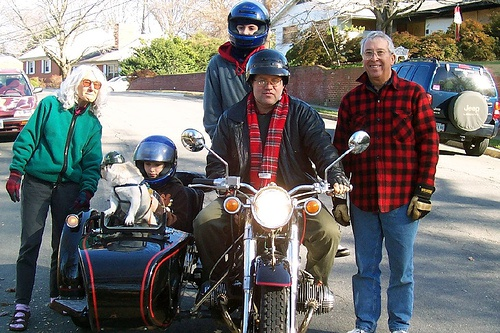Describe the objects in this image and their specific colors. I can see motorcycle in white, black, gray, and darkgray tones, people in white, black, maroon, navy, and blue tones, people in white, black, and teal tones, people in white, black, gray, maroon, and brown tones, and car in white, ivory, black, gray, and blue tones in this image. 